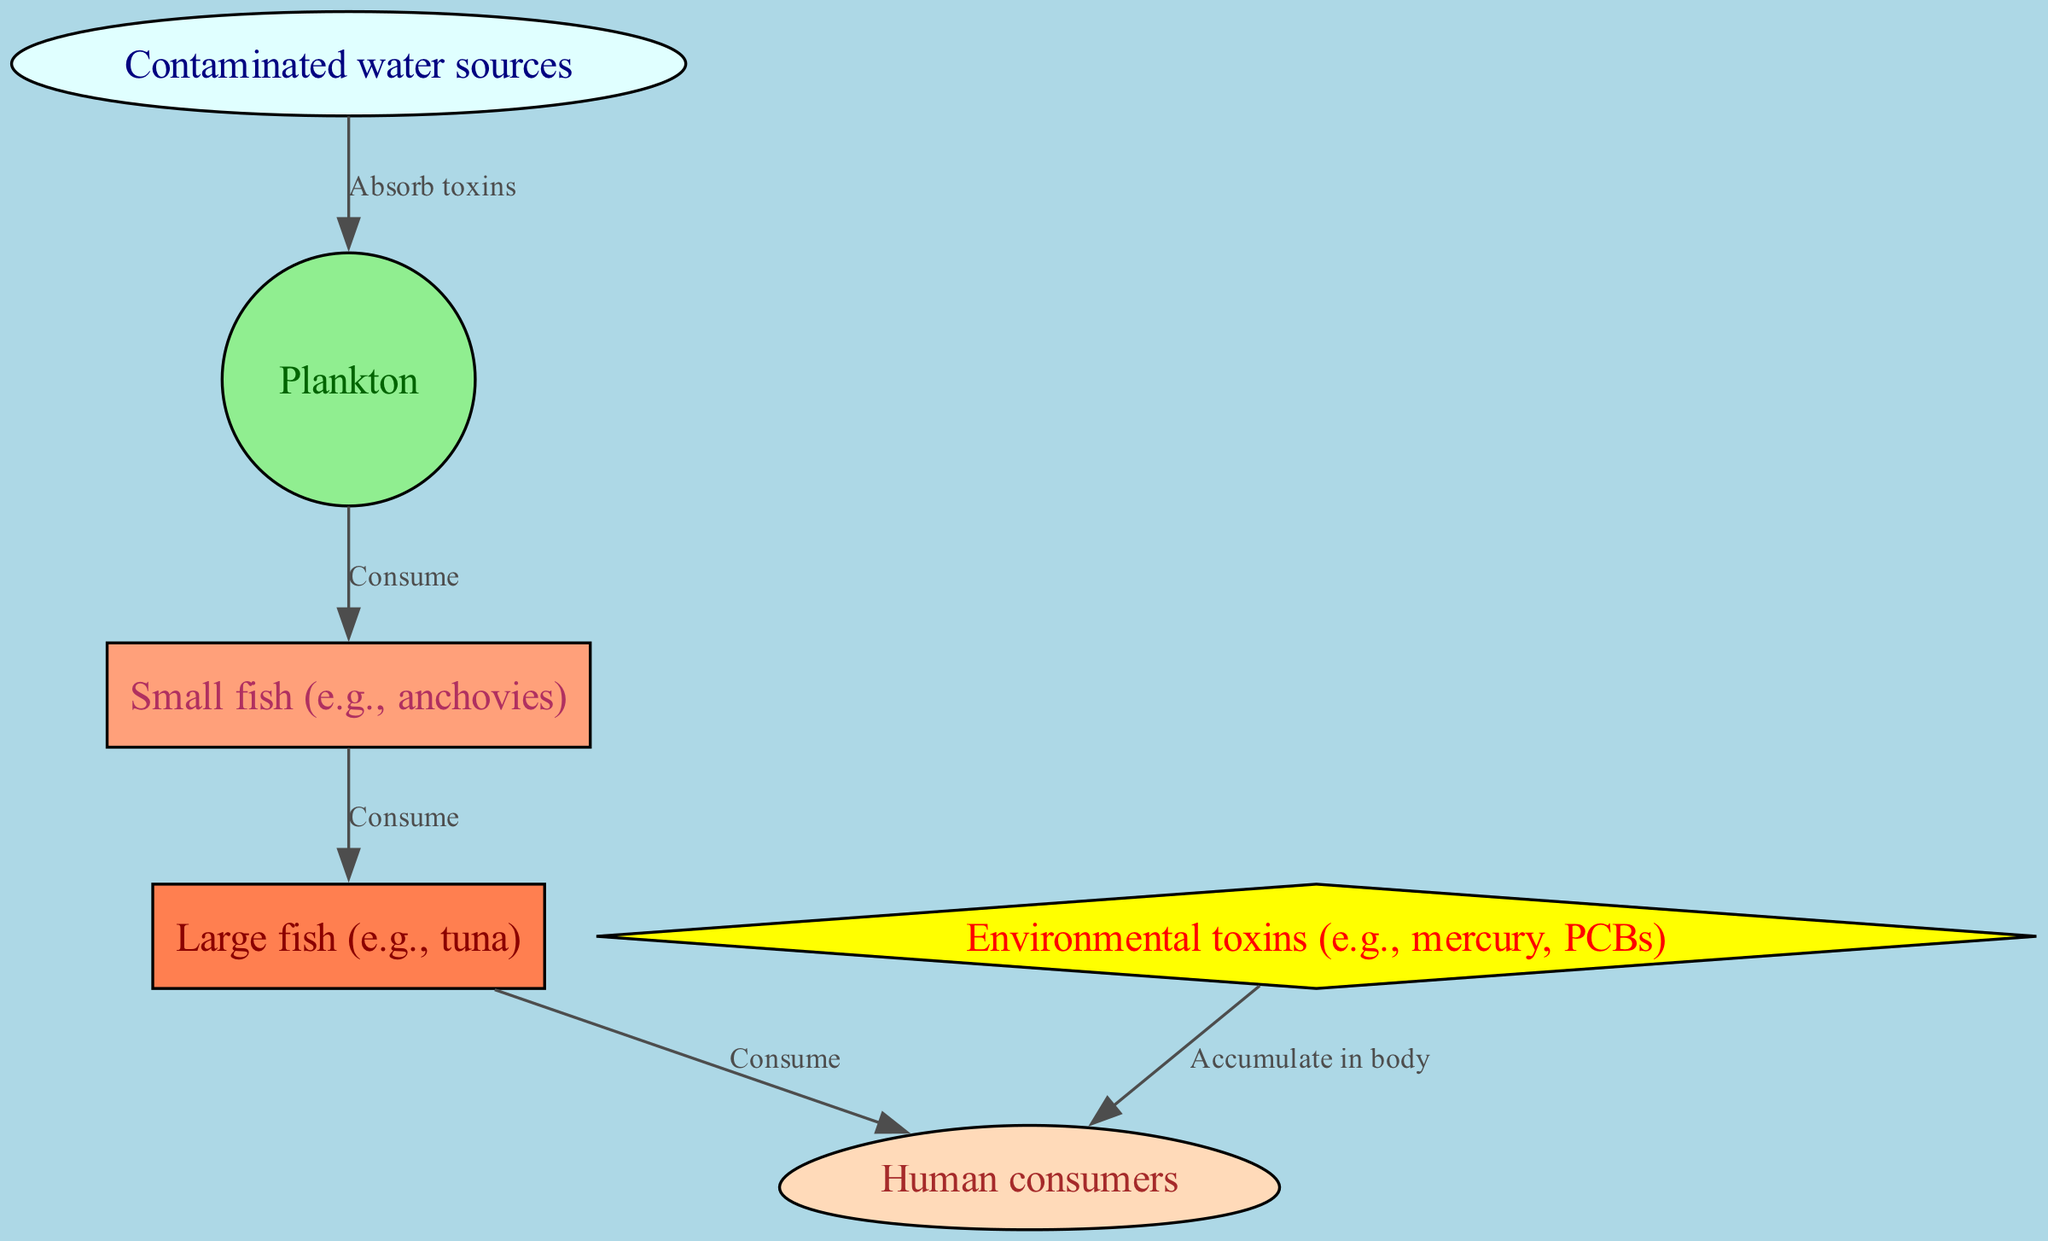What is the first element in the food chain? The diagram starts with "Contaminated water sources," which is represented as the first node.
Answer: Contaminated water sources How many nodes are in the diagram? Counting all unique elements, including water sources, organisms, and humans, the total is six nodes.
Answer: Six What do plankton do in this food chain? According to the diagram, plankton absorb toxins from contaminated water sources and then serve as a food source for small fish.
Answer: Absorb toxins Which organism consumes large fish? The diagram shows that humans are the consumers of large fish, which consume smaller fish.
Answer: Humans Which toxins are mentioned in the food chain? The diagram specifies "mercury" and "PCBs" as examples of environmental toxins affecting the food chain.
Answer: Mercury, PCBs What happens to toxins in humans? The diagram notes that toxins accumulate in the human body, indicating a significant health risk.
Answer: Accumulate in body What is the relationship between small fish and large fish? The connection shows that small fish consume plankton and are in turn consumed by large fish, establishing a predator-prey relationship.
Answer: Consume How many edges are there in total in this diagram? The diagram has five relationships or edges connecting the nodes, indicating the flow of energy and toxins.
Answer: Five 